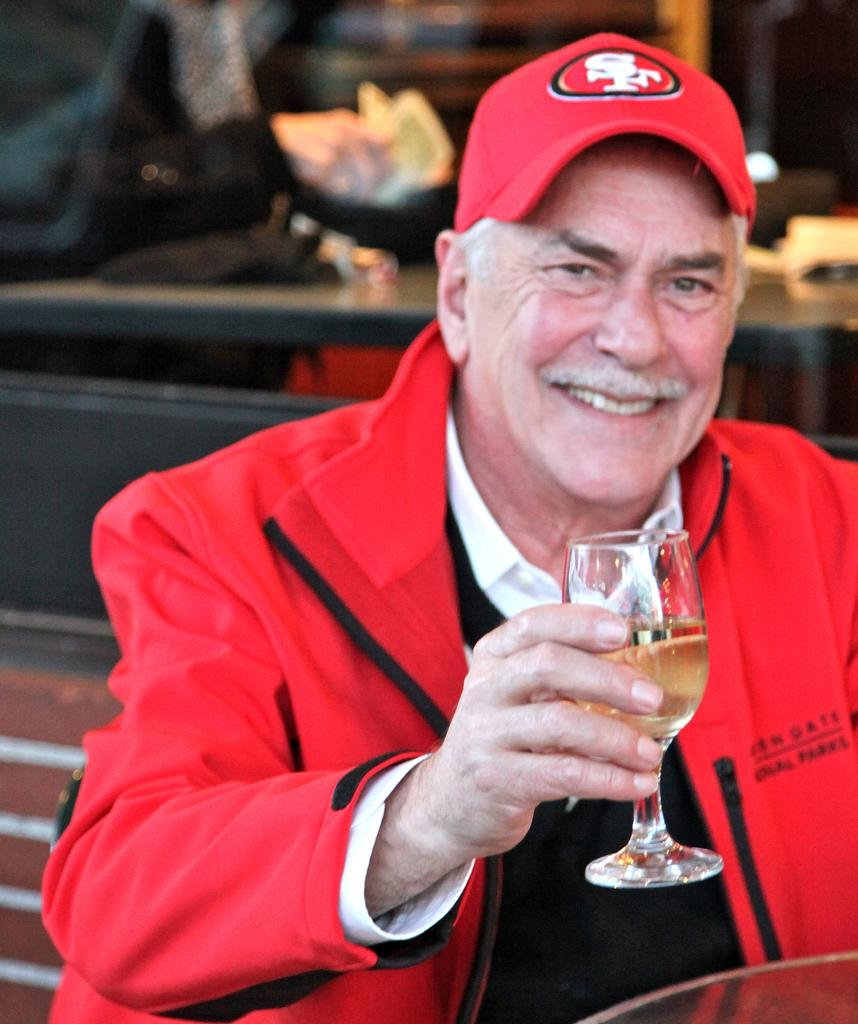Who is present in the image? There is a man in the image. What is the man wearing on his head? The man is wearing a cap. What is the man holding in his hands? The man is holding a glass with a drink in his hands. What is the man's facial expression? The man is smiling. What can be seen in the background of the image? There is a table in the background of the image. What type of scent can be detected from the man's face in the image? There is no information about the scent of the man's face in the image, as it is a visual medium. 